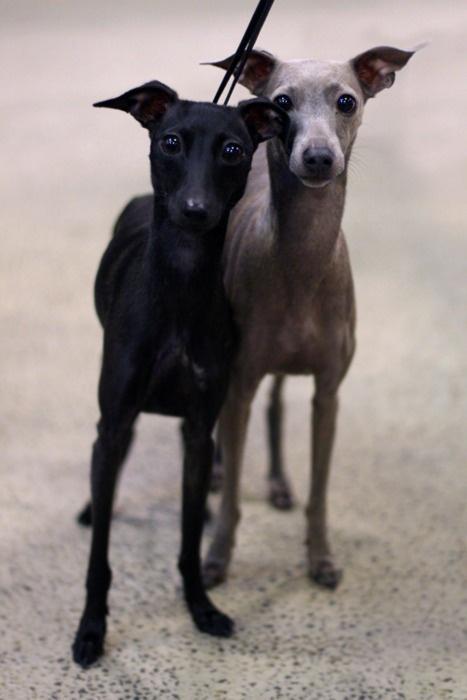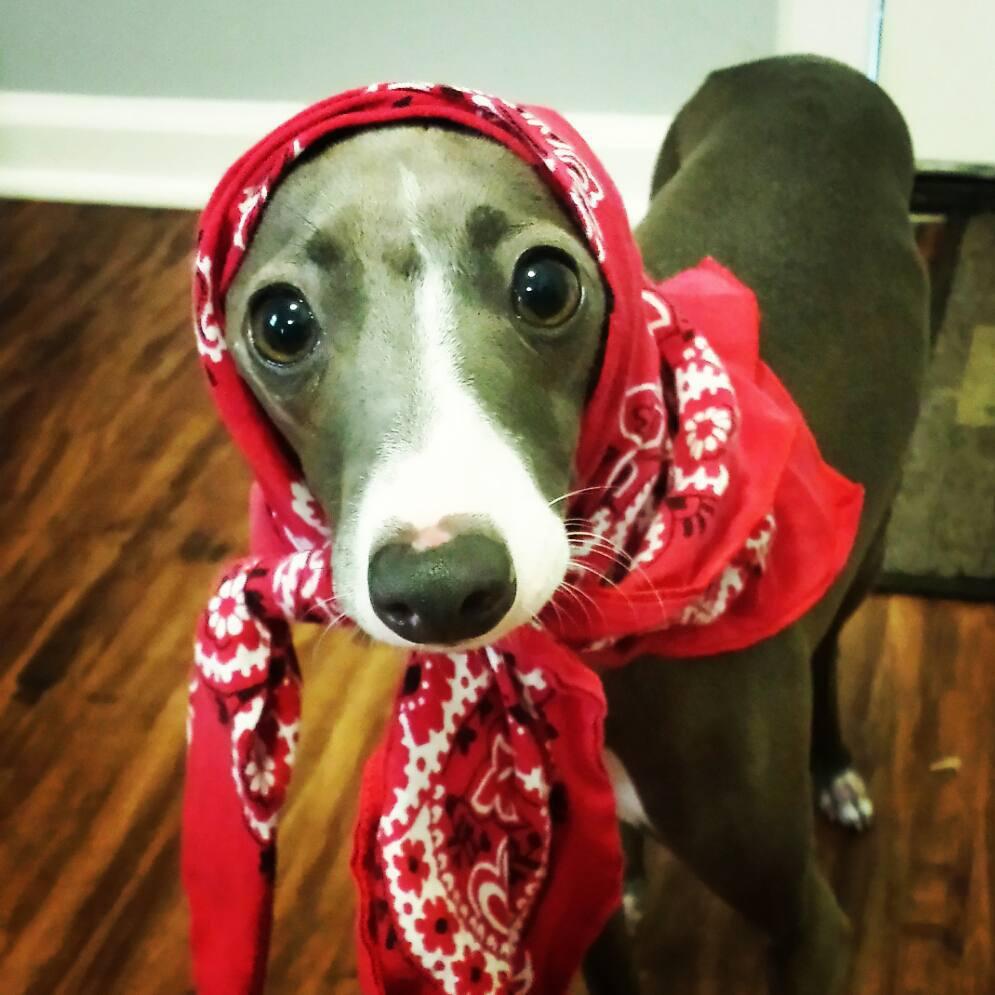The first image is the image on the left, the second image is the image on the right. For the images displayed, is the sentence "At least one greyhound is wearing something red." factually correct? Answer yes or no. Yes. The first image is the image on the left, the second image is the image on the right. Assess this claim about the two images: "At least one of the dogs is on a leash.". Correct or not? Answer yes or no. Yes. 